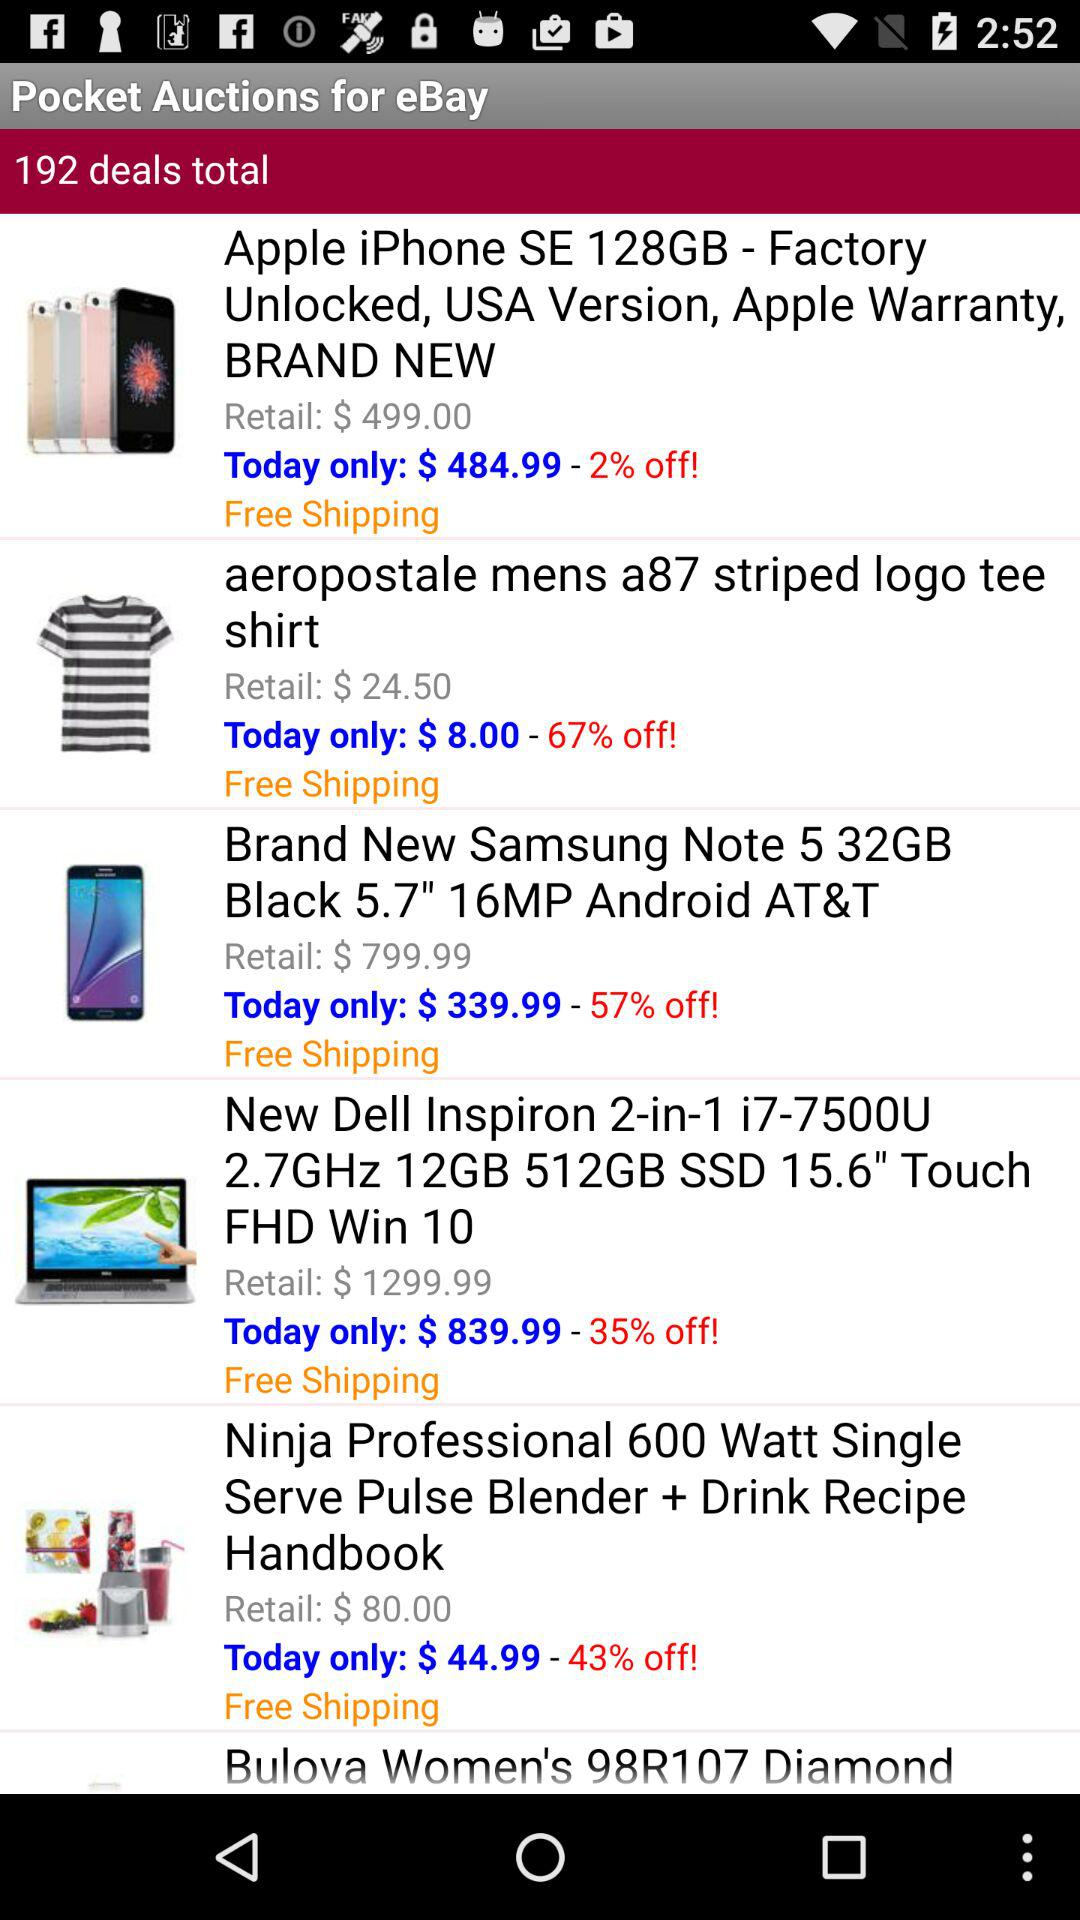What is the percentage off on the "aeropostale mens a87 striped logo tee shirt"? There is 67% off on the "aeropostale mens a87 striped logo tee shirt". 